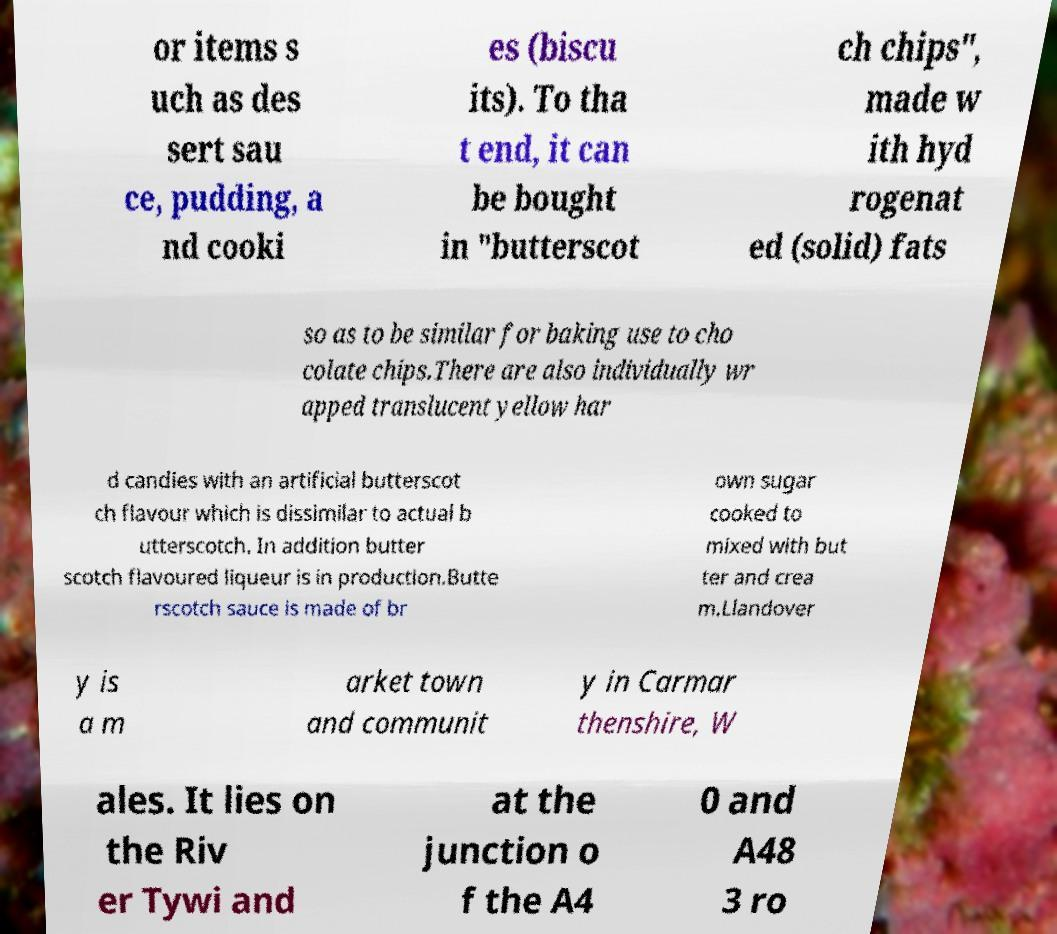Can you read and provide the text displayed in the image?This photo seems to have some interesting text. Can you extract and type it out for me? or items s uch as des sert sau ce, pudding, a nd cooki es (biscu its). To tha t end, it can be bought in "butterscot ch chips", made w ith hyd rogenat ed (solid) fats so as to be similar for baking use to cho colate chips.There are also individually wr apped translucent yellow har d candies with an artificial butterscot ch flavour which is dissimilar to actual b utterscotch. In addition butter scotch flavoured liqueur is in production.Butte rscotch sauce is made of br own sugar cooked to mixed with but ter and crea m.Llandover y is a m arket town and communit y in Carmar thenshire, W ales. It lies on the Riv er Tywi and at the junction o f the A4 0 and A48 3 ro 